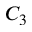Convert formula to latex. <formula><loc_0><loc_0><loc_500><loc_500>C _ { 3 }</formula> 